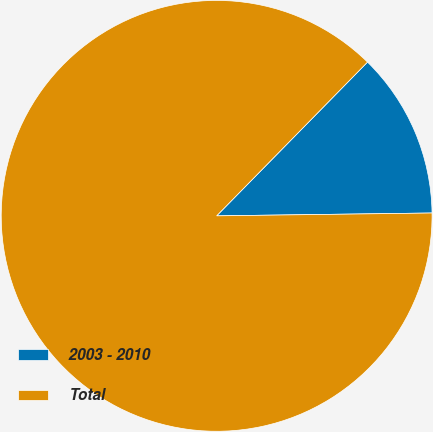Convert chart to OTSL. <chart><loc_0><loc_0><loc_500><loc_500><pie_chart><fcel>2003 - 2010<fcel>Total<nl><fcel>12.44%<fcel>87.56%<nl></chart> 